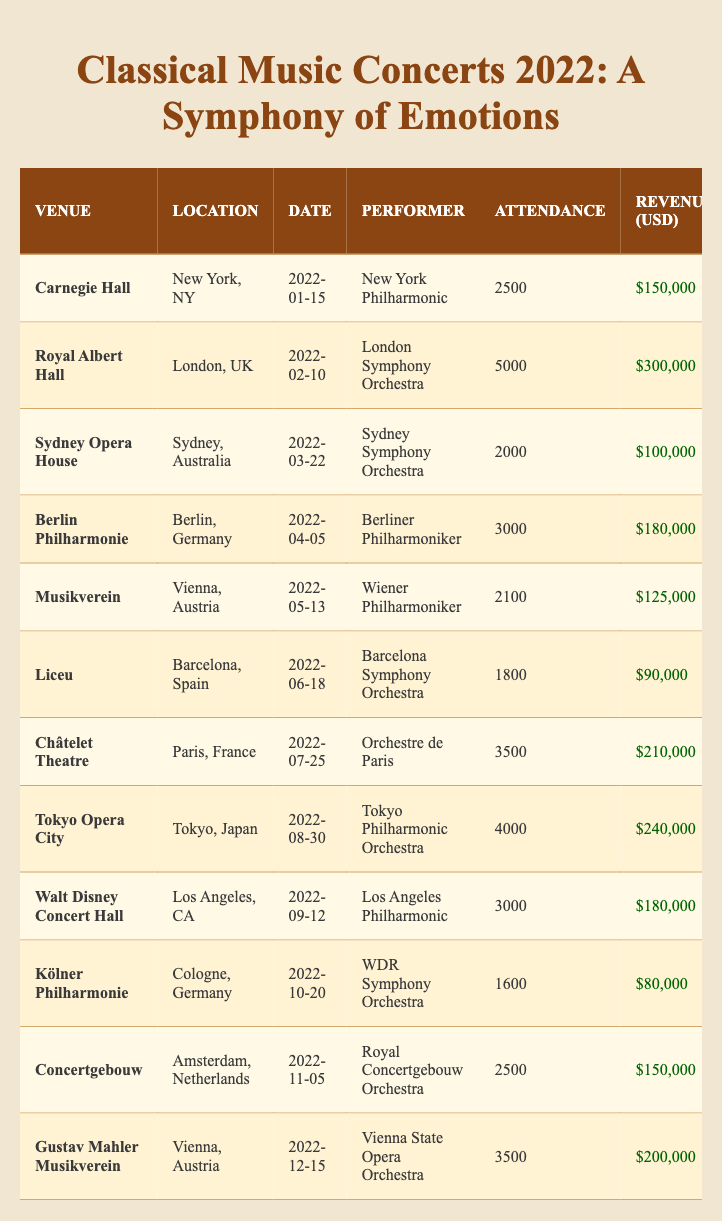What is the emotion theme of the concert held at Carnegie Hall? The table shows the performance details for Carnegie Hall, which lists the emotion theme as "Triumph."
Answer: Triumph How many attendees were present at the Royal Albert Hall concert? According to the table, the attendance listed for the Royal Albert Hall concert is 5000.
Answer: 5000 What was the total revenue from the concerts held in Vienna? The concerts held in Vienna were at Musikverein with $125,000 and Gustav Mahler Musikverein with $200,000. Adding these gives $125,000 + $200,000 = $325,000.
Answer: $325,000 Which concert had the highest attendance? By examining the attendance figures, the Royal Albert Hall concert had the highest attendance at 5000.
Answer: 5000 What was the mean ticket price across all the concerts? The ticket prices are $60, $80, $50, $60, $75, $50, $60, $60, $60, $50, $60, $70. Adding these gives $60 + $80 + $50 + $60 + $75 + $50 + $60 + $60 + $60 + $50 + $60 + $70 = $735. With 12 concerts, the mean is $735/12 = $61.25.
Answer: $61.25 Did the Tokyo Philharmonic Orchestra's concert generate more than $200,000 in revenue? The revenue for the Tokyo Philharmonic Orchestra's concert is listed as $240,000, which is greater than $200,000.
Answer: Yes Which emotion theme most frequently appears in the concerts listed? From the data, I can count the occurrences of each emotion theme: "Triumph" (1), "Nostalgia" (1), "Melancholy" (1), "Elation" (1), "Reverence" (1), "Passion" (1), "Joy" (1), "Surprise" (1), "Hope" (1), "Reflection" (1), "Celebration" (1), "Ecstasy" (1). Each appears only once, making no theme more frequent.
Answer: No theme is more frequent What is the difference in attendance between the concert at Châtelet Theatre and the concert at Kölner Philharmonie? The attendance at Châtelet Theatre was 3500 and at Kölner Philharmonie was 1600. The difference is 3500 - 1600 = 1900.
Answer: 1900 How much revenue was generated from concerts expressing 'Joy' and 'Ecstasy'? The revenue for 'Joy' at Châtelet Theatre is $210,000, and for 'Ecstasy' at Gustav Mahler Musikverein, it is $200,000. Adding these gives $210,000 + $200,000 = $410,000.
Answer: $410,000 Which concert had the lowest attendance? By inspecting the attendance values, Kölner Philharmonie had the lowest attendance at 1600.
Answer: 1600 